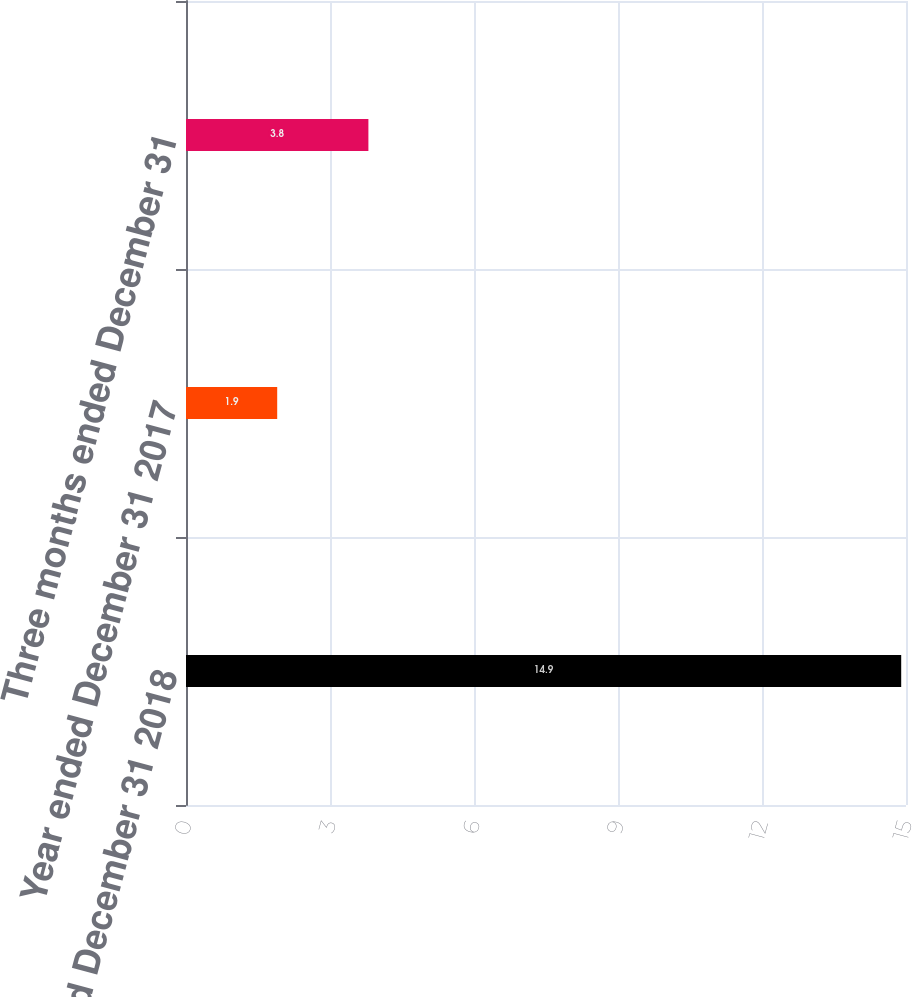Convert chart. <chart><loc_0><loc_0><loc_500><loc_500><bar_chart><fcel>Year ended December 31 2018<fcel>Year ended December 31 2017<fcel>Three months ended December 31<nl><fcel>14.9<fcel>1.9<fcel>3.8<nl></chart> 